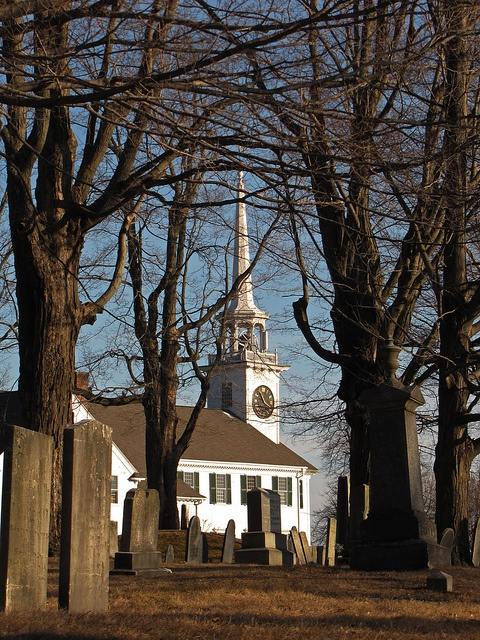Describe the objects in this image and their specific colors. I can see a clock in black, gray, and maroon tones in this image. 